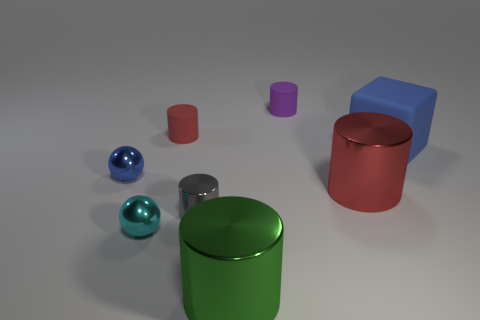Subtract all red cylinders. How many were subtracted if there are1red cylinders left? 1 Subtract all green cylinders. How many cylinders are left? 4 Subtract all red metallic cylinders. How many cylinders are left? 4 Subtract all blue cylinders. Subtract all blue spheres. How many cylinders are left? 5 Add 1 big yellow rubber objects. How many objects exist? 9 Subtract all blocks. How many objects are left? 7 Add 2 cyan shiny spheres. How many cyan shiny spheres exist? 3 Subtract 0 green blocks. How many objects are left? 8 Subtract all red metallic things. Subtract all large blue objects. How many objects are left? 6 Add 3 large matte cubes. How many large matte cubes are left? 4 